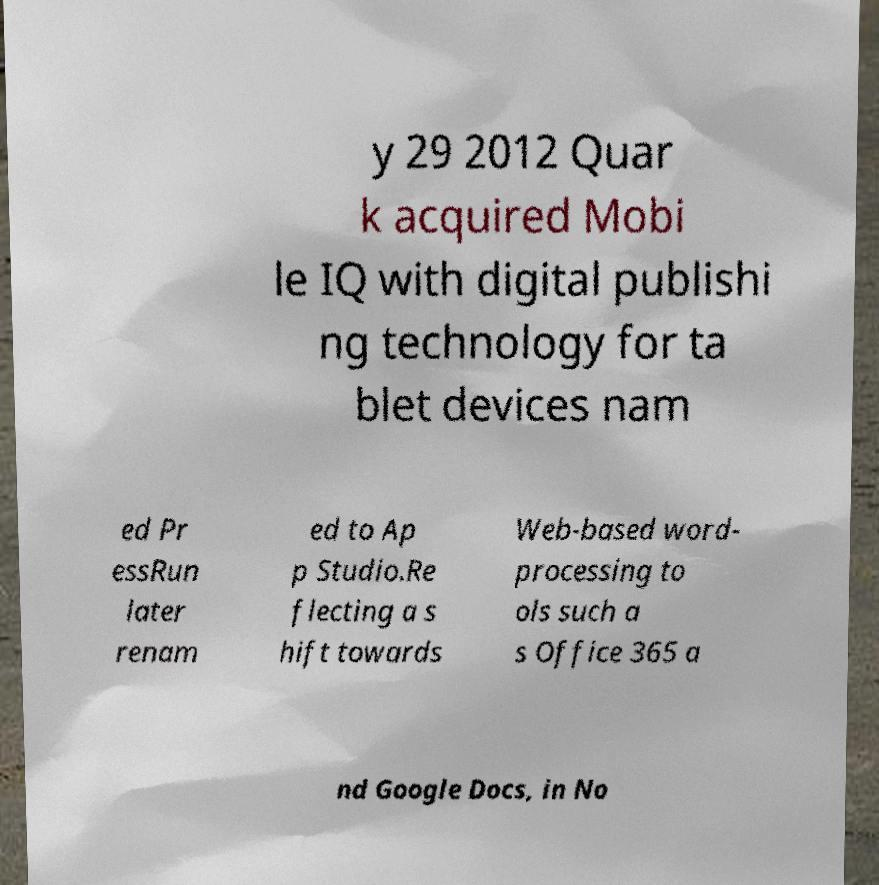Please identify and transcribe the text found in this image. y 29 2012 Quar k acquired Mobi le IQ with digital publishi ng technology for ta blet devices nam ed Pr essRun later renam ed to Ap p Studio.Re flecting a s hift towards Web-based word- processing to ols such a s Office 365 a nd Google Docs, in No 